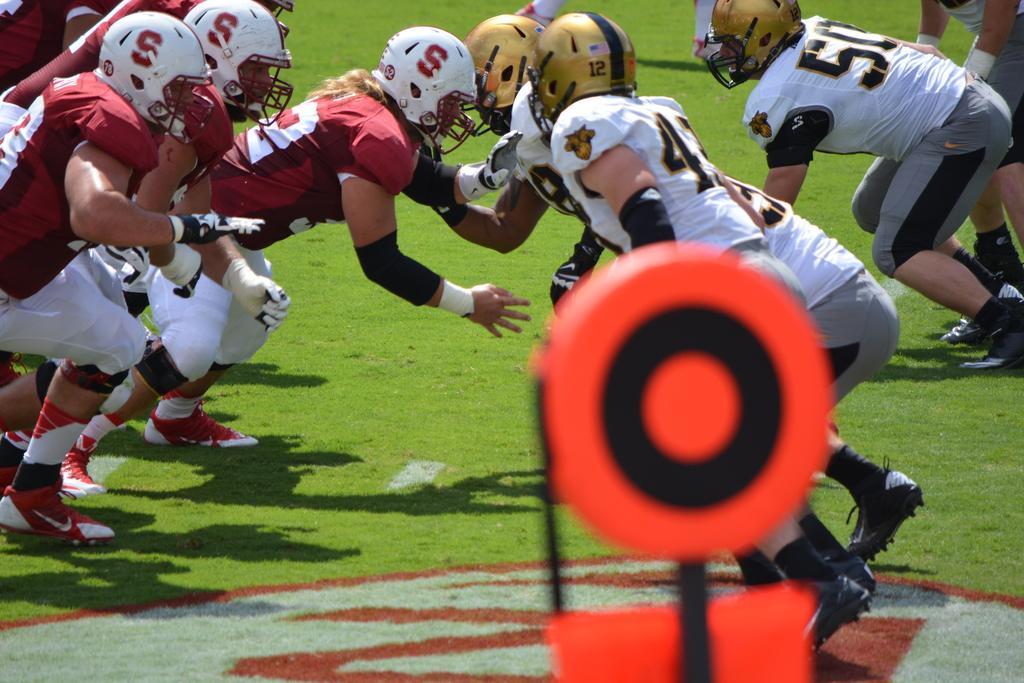Describe this image in one or two sentences. In this image it seems like it is a rugby match where there are players of two different teams are facing each other. They are wearing jerseys and helmets. At the bottom there is ground. 